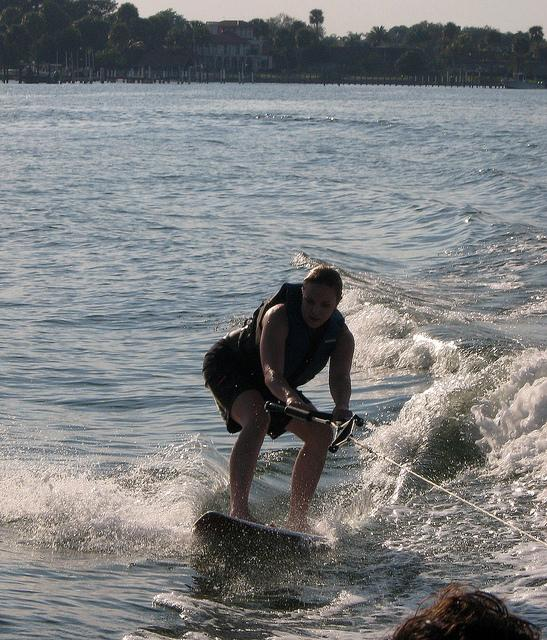What is the name of the safety garment the wakeboarder is wearing? Please explain your reasoning. life vest. A life vest keeps the person safe from falling in the water. 